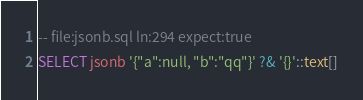Convert code to text. <code><loc_0><loc_0><loc_500><loc_500><_SQL_>-- file:jsonb.sql ln:294 expect:true
SELECT jsonb '{"a":null, "b":"qq"}' ?& '{}'::text[]
</code> 